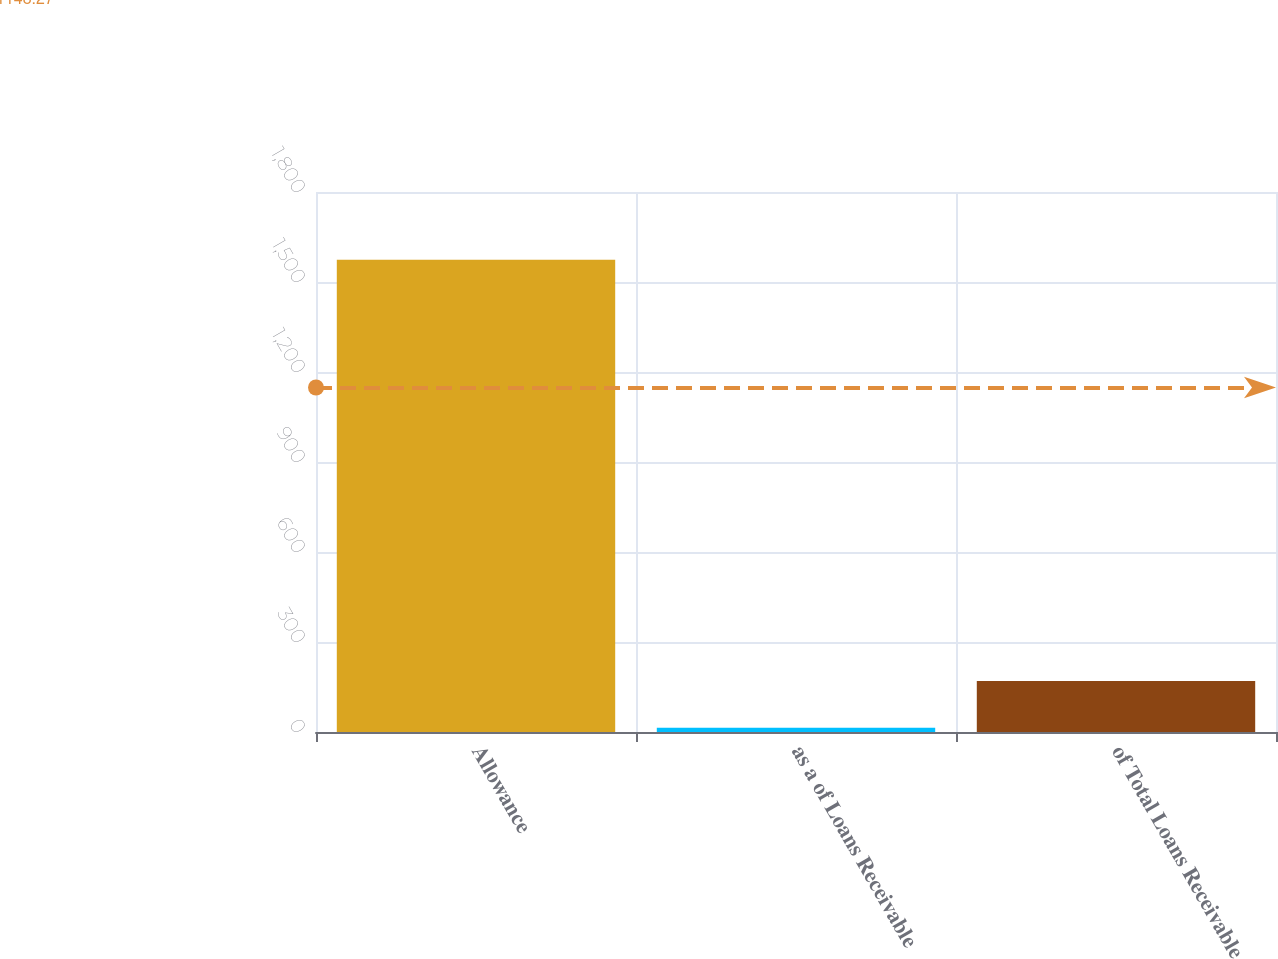<chart> <loc_0><loc_0><loc_500><loc_500><bar_chart><fcel>Allowance<fcel>as a of Loans Receivable<fcel>of Total Loans Receivable<nl><fcel>1574<fcel>14<fcel>170<nl></chart> 